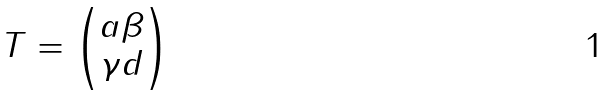<formula> <loc_0><loc_0><loc_500><loc_500>T = \begin{pmatrix} a \beta \\ \gamma d \end{pmatrix}</formula> 